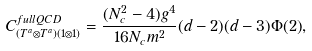<formula> <loc_0><loc_0><loc_500><loc_500>C ^ { f u l l Q C D } _ { ( T ^ { a } \otimes T ^ { a } ) ( 1 \otimes 1 ) } = \frac { ( N _ { c } ^ { 2 } - 4 ) g ^ { 4 } } { 1 6 N _ { c } m ^ { 2 } } ( d - 2 ) ( d - 3 ) \Phi ( 2 ) ,</formula> 